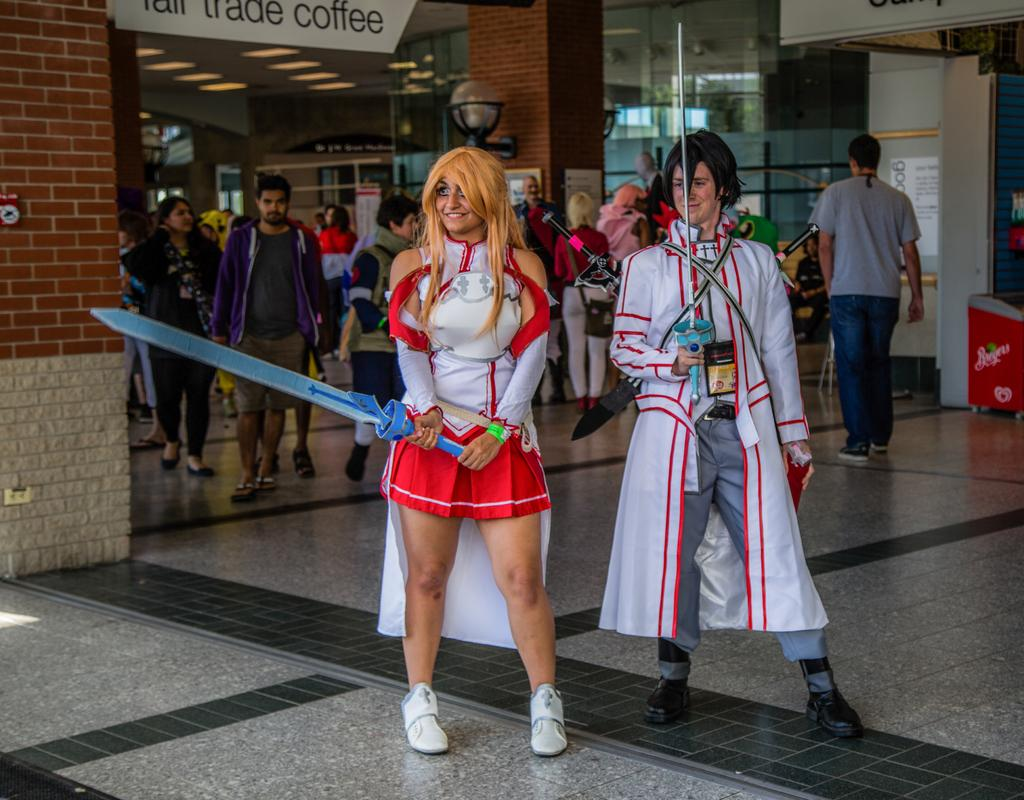<image>
Summarize the visual content of the image. Two cosplayers with swords in front of a sign for fair trade coffee. 